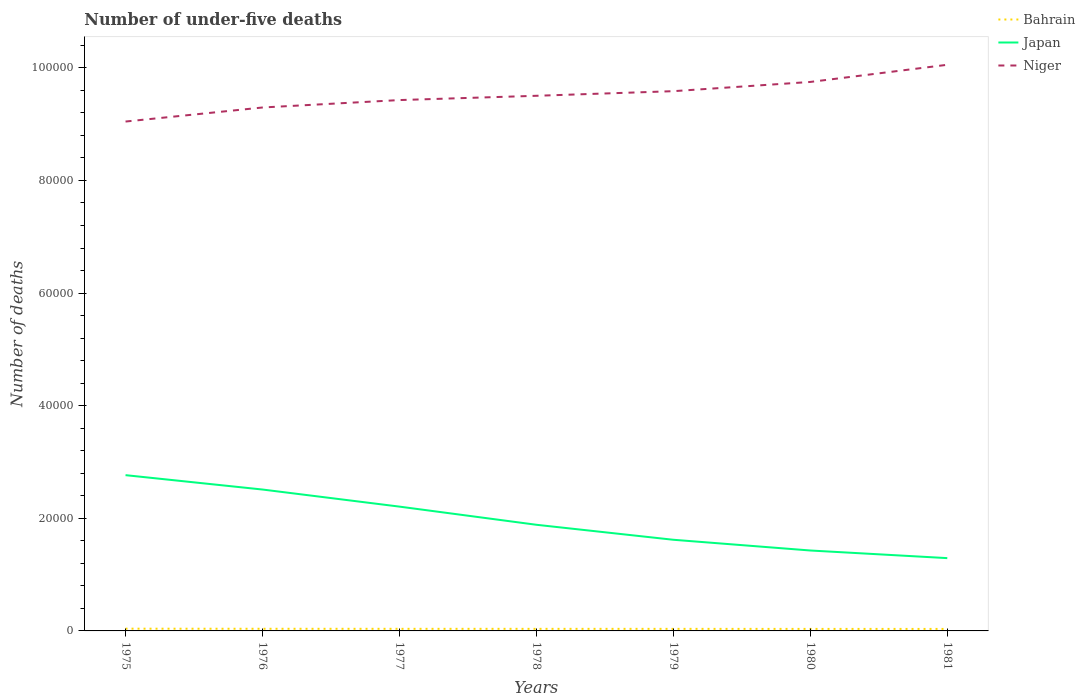Is the number of lines equal to the number of legend labels?
Provide a short and direct response. Yes. Across all years, what is the maximum number of under-five deaths in Bahrain?
Offer a very short reply. 355. What is the total number of under-five deaths in Niger in the graph?
Your answer should be very brief. -3219. What is the difference between the highest and the second highest number of under-five deaths in Bahrain?
Keep it short and to the point. 44. How many lines are there?
Offer a very short reply. 3. How many years are there in the graph?
Make the answer very short. 7. Are the values on the major ticks of Y-axis written in scientific E-notation?
Offer a terse response. No. Does the graph contain grids?
Give a very brief answer. No. What is the title of the graph?
Your answer should be very brief. Number of under-five deaths. Does "Heavily indebted poor countries" appear as one of the legend labels in the graph?
Offer a terse response. No. What is the label or title of the Y-axis?
Keep it short and to the point. Number of deaths. What is the Number of deaths of Bahrain in 1975?
Your response must be concise. 399. What is the Number of deaths in Japan in 1975?
Your answer should be very brief. 2.77e+04. What is the Number of deaths of Niger in 1975?
Offer a terse response. 9.05e+04. What is the Number of deaths in Bahrain in 1976?
Keep it short and to the point. 381. What is the Number of deaths of Japan in 1976?
Offer a very short reply. 2.51e+04. What is the Number of deaths of Niger in 1976?
Offer a terse response. 9.30e+04. What is the Number of deaths of Bahrain in 1977?
Give a very brief answer. 373. What is the Number of deaths of Japan in 1977?
Make the answer very short. 2.21e+04. What is the Number of deaths of Niger in 1977?
Offer a terse response. 9.43e+04. What is the Number of deaths in Bahrain in 1978?
Your answer should be compact. 370. What is the Number of deaths of Japan in 1978?
Provide a succinct answer. 1.89e+04. What is the Number of deaths of Niger in 1978?
Make the answer very short. 9.50e+04. What is the Number of deaths of Bahrain in 1979?
Keep it short and to the point. 367. What is the Number of deaths of Japan in 1979?
Your response must be concise. 1.62e+04. What is the Number of deaths in Niger in 1979?
Keep it short and to the point. 9.59e+04. What is the Number of deaths in Bahrain in 1980?
Your answer should be very brief. 359. What is the Number of deaths of Japan in 1980?
Your answer should be very brief. 1.43e+04. What is the Number of deaths of Niger in 1980?
Make the answer very short. 9.75e+04. What is the Number of deaths in Bahrain in 1981?
Offer a very short reply. 355. What is the Number of deaths of Japan in 1981?
Offer a very short reply. 1.29e+04. What is the Number of deaths of Niger in 1981?
Provide a succinct answer. 1.01e+05. Across all years, what is the maximum Number of deaths of Bahrain?
Provide a succinct answer. 399. Across all years, what is the maximum Number of deaths of Japan?
Your answer should be very brief. 2.77e+04. Across all years, what is the maximum Number of deaths of Niger?
Offer a very short reply. 1.01e+05. Across all years, what is the minimum Number of deaths in Bahrain?
Keep it short and to the point. 355. Across all years, what is the minimum Number of deaths in Japan?
Give a very brief answer. 1.29e+04. Across all years, what is the minimum Number of deaths of Niger?
Provide a short and direct response. 9.05e+04. What is the total Number of deaths in Bahrain in the graph?
Provide a short and direct response. 2604. What is the total Number of deaths of Japan in the graph?
Keep it short and to the point. 1.37e+05. What is the total Number of deaths of Niger in the graph?
Your answer should be compact. 6.67e+05. What is the difference between the Number of deaths in Japan in 1975 and that in 1976?
Your response must be concise. 2553. What is the difference between the Number of deaths of Niger in 1975 and that in 1976?
Give a very brief answer. -2495. What is the difference between the Number of deaths in Bahrain in 1975 and that in 1977?
Offer a very short reply. 26. What is the difference between the Number of deaths in Japan in 1975 and that in 1977?
Provide a short and direct response. 5588. What is the difference between the Number of deaths in Niger in 1975 and that in 1977?
Offer a terse response. -3814. What is the difference between the Number of deaths of Bahrain in 1975 and that in 1978?
Ensure brevity in your answer.  29. What is the difference between the Number of deaths of Japan in 1975 and that in 1978?
Your response must be concise. 8812. What is the difference between the Number of deaths in Niger in 1975 and that in 1978?
Keep it short and to the point. -4574. What is the difference between the Number of deaths in Bahrain in 1975 and that in 1979?
Make the answer very short. 32. What is the difference between the Number of deaths in Japan in 1975 and that in 1979?
Provide a succinct answer. 1.15e+04. What is the difference between the Number of deaths of Niger in 1975 and that in 1979?
Provide a short and direct response. -5393. What is the difference between the Number of deaths of Bahrain in 1975 and that in 1980?
Ensure brevity in your answer.  40. What is the difference between the Number of deaths of Japan in 1975 and that in 1980?
Offer a terse response. 1.34e+04. What is the difference between the Number of deaths in Niger in 1975 and that in 1980?
Your response must be concise. -7033. What is the difference between the Number of deaths of Japan in 1975 and that in 1981?
Offer a very short reply. 1.47e+04. What is the difference between the Number of deaths of Niger in 1975 and that in 1981?
Make the answer very short. -1.01e+04. What is the difference between the Number of deaths of Bahrain in 1976 and that in 1977?
Provide a short and direct response. 8. What is the difference between the Number of deaths in Japan in 1976 and that in 1977?
Your answer should be compact. 3035. What is the difference between the Number of deaths of Niger in 1976 and that in 1977?
Your response must be concise. -1319. What is the difference between the Number of deaths of Bahrain in 1976 and that in 1978?
Your answer should be very brief. 11. What is the difference between the Number of deaths in Japan in 1976 and that in 1978?
Your answer should be very brief. 6259. What is the difference between the Number of deaths in Niger in 1976 and that in 1978?
Ensure brevity in your answer.  -2079. What is the difference between the Number of deaths of Bahrain in 1976 and that in 1979?
Your answer should be very brief. 14. What is the difference between the Number of deaths of Japan in 1976 and that in 1979?
Your answer should be very brief. 8922. What is the difference between the Number of deaths of Niger in 1976 and that in 1979?
Provide a succinct answer. -2898. What is the difference between the Number of deaths in Japan in 1976 and that in 1980?
Offer a very short reply. 1.08e+04. What is the difference between the Number of deaths in Niger in 1976 and that in 1980?
Offer a very short reply. -4538. What is the difference between the Number of deaths in Bahrain in 1976 and that in 1981?
Give a very brief answer. 26. What is the difference between the Number of deaths in Japan in 1976 and that in 1981?
Keep it short and to the point. 1.22e+04. What is the difference between the Number of deaths in Niger in 1976 and that in 1981?
Offer a terse response. -7585. What is the difference between the Number of deaths of Bahrain in 1977 and that in 1978?
Your answer should be very brief. 3. What is the difference between the Number of deaths in Japan in 1977 and that in 1978?
Keep it short and to the point. 3224. What is the difference between the Number of deaths in Niger in 1977 and that in 1978?
Offer a terse response. -760. What is the difference between the Number of deaths of Japan in 1977 and that in 1979?
Offer a terse response. 5887. What is the difference between the Number of deaths of Niger in 1977 and that in 1979?
Keep it short and to the point. -1579. What is the difference between the Number of deaths of Japan in 1977 and that in 1980?
Provide a short and direct response. 7793. What is the difference between the Number of deaths in Niger in 1977 and that in 1980?
Provide a short and direct response. -3219. What is the difference between the Number of deaths of Bahrain in 1977 and that in 1981?
Make the answer very short. 18. What is the difference between the Number of deaths in Japan in 1977 and that in 1981?
Give a very brief answer. 9147. What is the difference between the Number of deaths of Niger in 1977 and that in 1981?
Make the answer very short. -6266. What is the difference between the Number of deaths of Japan in 1978 and that in 1979?
Your answer should be very brief. 2663. What is the difference between the Number of deaths in Niger in 1978 and that in 1979?
Your answer should be compact. -819. What is the difference between the Number of deaths of Bahrain in 1978 and that in 1980?
Ensure brevity in your answer.  11. What is the difference between the Number of deaths in Japan in 1978 and that in 1980?
Your answer should be very brief. 4569. What is the difference between the Number of deaths of Niger in 1978 and that in 1980?
Your answer should be very brief. -2459. What is the difference between the Number of deaths of Japan in 1978 and that in 1981?
Your answer should be compact. 5923. What is the difference between the Number of deaths of Niger in 1978 and that in 1981?
Give a very brief answer. -5506. What is the difference between the Number of deaths of Bahrain in 1979 and that in 1980?
Keep it short and to the point. 8. What is the difference between the Number of deaths in Japan in 1979 and that in 1980?
Ensure brevity in your answer.  1906. What is the difference between the Number of deaths in Niger in 1979 and that in 1980?
Provide a short and direct response. -1640. What is the difference between the Number of deaths of Japan in 1979 and that in 1981?
Keep it short and to the point. 3260. What is the difference between the Number of deaths in Niger in 1979 and that in 1981?
Keep it short and to the point. -4687. What is the difference between the Number of deaths in Japan in 1980 and that in 1981?
Your answer should be very brief. 1354. What is the difference between the Number of deaths of Niger in 1980 and that in 1981?
Provide a succinct answer. -3047. What is the difference between the Number of deaths of Bahrain in 1975 and the Number of deaths of Japan in 1976?
Your response must be concise. -2.47e+04. What is the difference between the Number of deaths of Bahrain in 1975 and the Number of deaths of Niger in 1976?
Offer a terse response. -9.26e+04. What is the difference between the Number of deaths in Japan in 1975 and the Number of deaths in Niger in 1976?
Provide a short and direct response. -6.53e+04. What is the difference between the Number of deaths of Bahrain in 1975 and the Number of deaths of Japan in 1977?
Ensure brevity in your answer.  -2.17e+04. What is the difference between the Number of deaths of Bahrain in 1975 and the Number of deaths of Niger in 1977?
Provide a succinct answer. -9.39e+04. What is the difference between the Number of deaths in Japan in 1975 and the Number of deaths in Niger in 1977?
Your answer should be compact. -6.66e+04. What is the difference between the Number of deaths in Bahrain in 1975 and the Number of deaths in Japan in 1978?
Give a very brief answer. -1.85e+04. What is the difference between the Number of deaths in Bahrain in 1975 and the Number of deaths in Niger in 1978?
Make the answer very short. -9.46e+04. What is the difference between the Number of deaths in Japan in 1975 and the Number of deaths in Niger in 1978?
Offer a terse response. -6.74e+04. What is the difference between the Number of deaths of Bahrain in 1975 and the Number of deaths of Japan in 1979?
Offer a very short reply. -1.58e+04. What is the difference between the Number of deaths in Bahrain in 1975 and the Number of deaths in Niger in 1979?
Keep it short and to the point. -9.55e+04. What is the difference between the Number of deaths in Japan in 1975 and the Number of deaths in Niger in 1979?
Your response must be concise. -6.82e+04. What is the difference between the Number of deaths in Bahrain in 1975 and the Number of deaths in Japan in 1980?
Offer a very short reply. -1.39e+04. What is the difference between the Number of deaths in Bahrain in 1975 and the Number of deaths in Niger in 1980?
Your response must be concise. -9.71e+04. What is the difference between the Number of deaths of Japan in 1975 and the Number of deaths of Niger in 1980?
Your answer should be compact. -6.98e+04. What is the difference between the Number of deaths in Bahrain in 1975 and the Number of deaths in Japan in 1981?
Your answer should be compact. -1.25e+04. What is the difference between the Number of deaths of Bahrain in 1975 and the Number of deaths of Niger in 1981?
Your answer should be compact. -1.00e+05. What is the difference between the Number of deaths in Japan in 1975 and the Number of deaths in Niger in 1981?
Your response must be concise. -7.29e+04. What is the difference between the Number of deaths in Bahrain in 1976 and the Number of deaths in Japan in 1977?
Your response must be concise. -2.17e+04. What is the difference between the Number of deaths in Bahrain in 1976 and the Number of deaths in Niger in 1977?
Keep it short and to the point. -9.39e+04. What is the difference between the Number of deaths of Japan in 1976 and the Number of deaths of Niger in 1977?
Give a very brief answer. -6.92e+04. What is the difference between the Number of deaths of Bahrain in 1976 and the Number of deaths of Japan in 1978?
Give a very brief answer. -1.85e+04. What is the difference between the Number of deaths of Bahrain in 1976 and the Number of deaths of Niger in 1978?
Offer a terse response. -9.47e+04. What is the difference between the Number of deaths in Japan in 1976 and the Number of deaths in Niger in 1978?
Your response must be concise. -6.99e+04. What is the difference between the Number of deaths in Bahrain in 1976 and the Number of deaths in Japan in 1979?
Ensure brevity in your answer.  -1.58e+04. What is the difference between the Number of deaths in Bahrain in 1976 and the Number of deaths in Niger in 1979?
Keep it short and to the point. -9.55e+04. What is the difference between the Number of deaths in Japan in 1976 and the Number of deaths in Niger in 1979?
Offer a very short reply. -7.07e+04. What is the difference between the Number of deaths in Bahrain in 1976 and the Number of deaths in Japan in 1980?
Provide a short and direct response. -1.39e+04. What is the difference between the Number of deaths in Bahrain in 1976 and the Number of deaths in Niger in 1980?
Keep it short and to the point. -9.71e+04. What is the difference between the Number of deaths of Japan in 1976 and the Number of deaths of Niger in 1980?
Give a very brief answer. -7.24e+04. What is the difference between the Number of deaths of Bahrain in 1976 and the Number of deaths of Japan in 1981?
Your response must be concise. -1.25e+04. What is the difference between the Number of deaths in Bahrain in 1976 and the Number of deaths in Niger in 1981?
Your response must be concise. -1.00e+05. What is the difference between the Number of deaths in Japan in 1976 and the Number of deaths in Niger in 1981?
Provide a short and direct response. -7.54e+04. What is the difference between the Number of deaths in Bahrain in 1977 and the Number of deaths in Japan in 1978?
Offer a very short reply. -1.85e+04. What is the difference between the Number of deaths of Bahrain in 1977 and the Number of deaths of Niger in 1978?
Ensure brevity in your answer.  -9.47e+04. What is the difference between the Number of deaths in Japan in 1977 and the Number of deaths in Niger in 1978?
Make the answer very short. -7.30e+04. What is the difference between the Number of deaths in Bahrain in 1977 and the Number of deaths in Japan in 1979?
Offer a terse response. -1.58e+04. What is the difference between the Number of deaths of Bahrain in 1977 and the Number of deaths of Niger in 1979?
Offer a very short reply. -9.55e+04. What is the difference between the Number of deaths in Japan in 1977 and the Number of deaths in Niger in 1979?
Provide a short and direct response. -7.38e+04. What is the difference between the Number of deaths of Bahrain in 1977 and the Number of deaths of Japan in 1980?
Your answer should be compact. -1.39e+04. What is the difference between the Number of deaths in Bahrain in 1977 and the Number of deaths in Niger in 1980?
Keep it short and to the point. -9.71e+04. What is the difference between the Number of deaths of Japan in 1977 and the Number of deaths of Niger in 1980?
Provide a short and direct response. -7.54e+04. What is the difference between the Number of deaths in Bahrain in 1977 and the Number of deaths in Japan in 1981?
Your response must be concise. -1.26e+04. What is the difference between the Number of deaths in Bahrain in 1977 and the Number of deaths in Niger in 1981?
Your response must be concise. -1.00e+05. What is the difference between the Number of deaths in Japan in 1977 and the Number of deaths in Niger in 1981?
Keep it short and to the point. -7.85e+04. What is the difference between the Number of deaths of Bahrain in 1978 and the Number of deaths of Japan in 1979?
Offer a very short reply. -1.58e+04. What is the difference between the Number of deaths in Bahrain in 1978 and the Number of deaths in Niger in 1979?
Offer a very short reply. -9.55e+04. What is the difference between the Number of deaths in Japan in 1978 and the Number of deaths in Niger in 1979?
Ensure brevity in your answer.  -7.70e+04. What is the difference between the Number of deaths in Bahrain in 1978 and the Number of deaths in Japan in 1980?
Your answer should be compact. -1.39e+04. What is the difference between the Number of deaths of Bahrain in 1978 and the Number of deaths of Niger in 1980?
Your answer should be very brief. -9.71e+04. What is the difference between the Number of deaths of Japan in 1978 and the Number of deaths of Niger in 1980?
Your answer should be very brief. -7.86e+04. What is the difference between the Number of deaths in Bahrain in 1978 and the Number of deaths in Japan in 1981?
Provide a short and direct response. -1.26e+04. What is the difference between the Number of deaths of Bahrain in 1978 and the Number of deaths of Niger in 1981?
Provide a short and direct response. -1.00e+05. What is the difference between the Number of deaths in Japan in 1978 and the Number of deaths in Niger in 1981?
Your answer should be very brief. -8.17e+04. What is the difference between the Number of deaths of Bahrain in 1979 and the Number of deaths of Japan in 1980?
Make the answer very short. -1.39e+04. What is the difference between the Number of deaths in Bahrain in 1979 and the Number of deaths in Niger in 1980?
Offer a very short reply. -9.71e+04. What is the difference between the Number of deaths in Japan in 1979 and the Number of deaths in Niger in 1980?
Give a very brief answer. -8.13e+04. What is the difference between the Number of deaths of Bahrain in 1979 and the Number of deaths of Japan in 1981?
Keep it short and to the point. -1.26e+04. What is the difference between the Number of deaths in Bahrain in 1979 and the Number of deaths in Niger in 1981?
Offer a very short reply. -1.00e+05. What is the difference between the Number of deaths in Japan in 1979 and the Number of deaths in Niger in 1981?
Ensure brevity in your answer.  -8.44e+04. What is the difference between the Number of deaths of Bahrain in 1980 and the Number of deaths of Japan in 1981?
Keep it short and to the point. -1.26e+04. What is the difference between the Number of deaths of Bahrain in 1980 and the Number of deaths of Niger in 1981?
Keep it short and to the point. -1.00e+05. What is the difference between the Number of deaths of Japan in 1980 and the Number of deaths of Niger in 1981?
Offer a terse response. -8.63e+04. What is the average Number of deaths of Bahrain per year?
Your answer should be compact. 372. What is the average Number of deaths in Japan per year?
Your answer should be very brief. 1.96e+04. What is the average Number of deaths of Niger per year?
Your answer should be compact. 9.52e+04. In the year 1975, what is the difference between the Number of deaths of Bahrain and Number of deaths of Japan?
Give a very brief answer. -2.73e+04. In the year 1975, what is the difference between the Number of deaths of Bahrain and Number of deaths of Niger?
Keep it short and to the point. -9.01e+04. In the year 1975, what is the difference between the Number of deaths in Japan and Number of deaths in Niger?
Provide a short and direct response. -6.28e+04. In the year 1976, what is the difference between the Number of deaths of Bahrain and Number of deaths of Japan?
Your response must be concise. -2.47e+04. In the year 1976, what is the difference between the Number of deaths in Bahrain and Number of deaths in Niger?
Offer a terse response. -9.26e+04. In the year 1976, what is the difference between the Number of deaths of Japan and Number of deaths of Niger?
Provide a succinct answer. -6.78e+04. In the year 1977, what is the difference between the Number of deaths in Bahrain and Number of deaths in Japan?
Keep it short and to the point. -2.17e+04. In the year 1977, what is the difference between the Number of deaths of Bahrain and Number of deaths of Niger?
Keep it short and to the point. -9.39e+04. In the year 1977, what is the difference between the Number of deaths in Japan and Number of deaths in Niger?
Your answer should be very brief. -7.22e+04. In the year 1978, what is the difference between the Number of deaths in Bahrain and Number of deaths in Japan?
Ensure brevity in your answer.  -1.85e+04. In the year 1978, what is the difference between the Number of deaths in Bahrain and Number of deaths in Niger?
Give a very brief answer. -9.47e+04. In the year 1978, what is the difference between the Number of deaths in Japan and Number of deaths in Niger?
Your response must be concise. -7.62e+04. In the year 1979, what is the difference between the Number of deaths in Bahrain and Number of deaths in Japan?
Your answer should be very brief. -1.58e+04. In the year 1979, what is the difference between the Number of deaths in Bahrain and Number of deaths in Niger?
Your answer should be compact. -9.55e+04. In the year 1979, what is the difference between the Number of deaths in Japan and Number of deaths in Niger?
Give a very brief answer. -7.97e+04. In the year 1980, what is the difference between the Number of deaths of Bahrain and Number of deaths of Japan?
Your answer should be compact. -1.39e+04. In the year 1980, what is the difference between the Number of deaths of Bahrain and Number of deaths of Niger?
Offer a very short reply. -9.71e+04. In the year 1980, what is the difference between the Number of deaths of Japan and Number of deaths of Niger?
Ensure brevity in your answer.  -8.32e+04. In the year 1981, what is the difference between the Number of deaths of Bahrain and Number of deaths of Japan?
Your answer should be very brief. -1.26e+04. In the year 1981, what is the difference between the Number of deaths in Bahrain and Number of deaths in Niger?
Your response must be concise. -1.00e+05. In the year 1981, what is the difference between the Number of deaths of Japan and Number of deaths of Niger?
Offer a terse response. -8.76e+04. What is the ratio of the Number of deaths in Bahrain in 1975 to that in 1976?
Offer a terse response. 1.05. What is the ratio of the Number of deaths in Japan in 1975 to that in 1976?
Offer a terse response. 1.1. What is the ratio of the Number of deaths in Niger in 1975 to that in 1976?
Provide a short and direct response. 0.97. What is the ratio of the Number of deaths in Bahrain in 1975 to that in 1977?
Your answer should be compact. 1.07. What is the ratio of the Number of deaths of Japan in 1975 to that in 1977?
Ensure brevity in your answer.  1.25. What is the ratio of the Number of deaths of Niger in 1975 to that in 1977?
Provide a short and direct response. 0.96. What is the ratio of the Number of deaths in Bahrain in 1975 to that in 1978?
Ensure brevity in your answer.  1.08. What is the ratio of the Number of deaths of Japan in 1975 to that in 1978?
Your response must be concise. 1.47. What is the ratio of the Number of deaths of Niger in 1975 to that in 1978?
Provide a succinct answer. 0.95. What is the ratio of the Number of deaths of Bahrain in 1975 to that in 1979?
Your response must be concise. 1.09. What is the ratio of the Number of deaths of Japan in 1975 to that in 1979?
Your response must be concise. 1.71. What is the ratio of the Number of deaths in Niger in 1975 to that in 1979?
Give a very brief answer. 0.94. What is the ratio of the Number of deaths in Bahrain in 1975 to that in 1980?
Provide a short and direct response. 1.11. What is the ratio of the Number of deaths in Japan in 1975 to that in 1980?
Give a very brief answer. 1.94. What is the ratio of the Number of deaths of Niger in 1975 to that in 1980?
Give a very brief answer. 0.93. What is the ratio of the Number of deaths of Bahrain in 1975 to that in 1981?
Keep it short and to the point. 1.12. What is the ratio of the Number of deaths of Japan in 1975 to that in 1981?
Offer a terse response. 2.14. What is the ratio of the Number of deaths in Niger in 1975 to that in 1981?
Keep it short and to the point. 0.9. What is the ratio of the Number of deaths of Bahrain in 1976 to that in 1977?
Ensure brevity in your answer.  1.02. What is the ratio of the Number of deaths of Japan in 1976 to that in 1977?
Keep it short and to the point. 1.14. What is the ratio of the Number of deaths of Niger in 1976 to that in 1977?
Give a very brief answer. 0.99. What is the ratio of the Number of deaths of Bahrain in 1976 to that in 1978?
Your response must be concise. 1.03. What is the ratio of the Number of deaths of Japan in 1976 to that in 1978?
Ensure brevity in your answer.  1.33. What is the ratio of the Number of deaths in Niger in 1976 to that in 1978?
Provide a succinct answer. 0.98. What is the ratio of the Number of deaths in Bahrain in 1976 to that in 1979?
Make the answer very short. 1.04. What is the ratio of the Number of deaths in Japan in 1976 to that in 1979?
Offer a very short reply. 1.55. What is the ratio of the Number of deaths in Niger in 1976 to that in 1979?
Offer a very short reply. 0.97. What is the ratio of the Number of deaths in Bahrain in 1976 to that in 1980?
Your response must be concise. 1.06. What is the ratio of the Number of deaths in Japan in 1976 to that in 1980?
Provide a succinct answer. 1.76. What is the ratio of the Number of deaths of Niger in 1976 to that in 1980?
Offer a terse response. 0.95. What is the ratio of the Number of deaths in Bahrain in 1976 to that in 1981?
Offer a very short reply. 1.07. What is the ratio of the Number of deaths of Japan in 1976 to that in 1981?
Provide a short and direct response. 1.94. What is the ratio of the Number of deaths in Niger in 1976 to that in 1981?
Keep it short and to the point. 0.92. What is the ratio of the Number of deaths in Bahrain in 1977 to that in 1978?
Offer a very short reply. 1.01. What is the ratio of the Number of deaths in Japan in 1977 to that in 1978?
Give a very brief answer. 1.17. What is the ratio of the Number of deaths in Niger in 1977 to that in 1978?
Make the answer very short. 0.99. What is the ratio of the Number of deaths in Bahrain in 1977 to that in 1979?
Provide a succinct answer. 1.02. What is the ratio of the Number of deaths of Japan in 1977 to that in 1979?
Keep it short and to the point. 1.36. What is the ratio of the Number of deaths in Niger in 1977 to that in 1979?
Your response must be concise. 0.98. What is the ratio of the Number of deaths of Bahrain in 1977 to that in 1980?
Ensure brevity in your answer.  1.04. What is the ratio of the Number of deaths in Japan in 1977 to that in 1980?
Your response must be concise. 1.55. What is the ratio of the Number of deaths of Niger in 1977 to that in 1980?
Provide a succinct answer. 0.97. What is the ratio of the Number of deaths of Bahrain in 1977 to that in 1981?
Make the answer very short. 1.05. What is the ratio of the Number of deaths in Japan in 1977 to that in 1981?
Give a very brief answer. 1.71. What is the ratio of the Number of deaths in Niger in 1977 to that in 1981?
Your answer should be compact. 0.94. What is the ratio of the Number of deaths of Bahrain in 1978 to that in 1979?
Make the answer very short. 1.01. What is the ratio of the Number of deaths in Japan in 1978 to that in 1979?
Provide a short and direct response. 1.16. What is the ratio of the Number of deaths of Bahrain in 1978 to that in 1980?
Your answer should be compact. 1.03. What is the ratio of the Number of deaths in Japan in 1978 to that in 1980?
Your answer should be compact. 1.32. What is the ratio of the Number of deaths of Niger in 1978 to that in 1980?
Your answer should be very brief. 0.97. What is the ratio of the Number of deaths in Bahrain in 1978 to that in 1981?
Make the answer very short. 1.04. What is the ratio of the Number of deaths of Japan in 1978 to that in 1981?
Provide a short and direct response. 1.46. What is the ratio of the Number of deaths of Niger in 1978 to that in 1981?
Provide a succinct answer. 0.95. What is the ratio of the Number of deaths in Bahrain in 1979 to that in 1980?
Your answer should be compact. 1.02. What is the ratio of the Number of deaths in Japan in 1979 to that in 1980?
Provide a succinct answer. 1.13. What is the ratio of the Number of deaths in Niger in 1979 to that in 1980?
Your answer should be compact. 0.98. What is the ratio of the Number of deaths of Bahrain in 1979 to that in 1981?
Provide a short and direct response. 1.03. What is the ratio of the Number of deaths in Japan in 1979 to that in 1981?
Your response must be concise. 1.25. What is the ratio of the Number of deaths of Niger in 1979 to that in 1981?
Make the answer very short. 0.95. What is the ratio of the Number of deaths of Bahrain in 1980 to that in 1981?
Give a very brief answer. 1.01. What is the ratio of the Number of deaths of Japan in 1980 to that in 1981?
Offer a terse response. 1.1. What is the ratio of the Number of deaths in Niger in 1980 to that in 1981?
Provide a short and direct response. 0.97. What is the difference between the highest and the second highest Number of deaths of Japan?
Keep it short and to the point. 2553. What is the difference between the highest and the second highest Number of deaths in Niger?
Your response must be concise. 3047. What is the difference between the highest and the lowest Number of deaths of Japan?
Keep it short and to the point. 1.47e+04. What is the difference between the highest and the lowest Number of deaths in Niger?
Your answer should be very brief. 1.01e+04. 